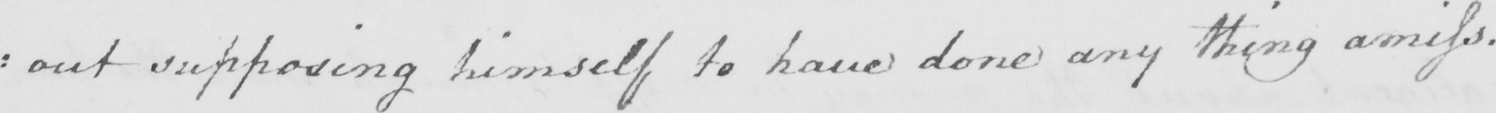What text is written in this handwritten line? : out supposing himself to have done any thing amiss . 